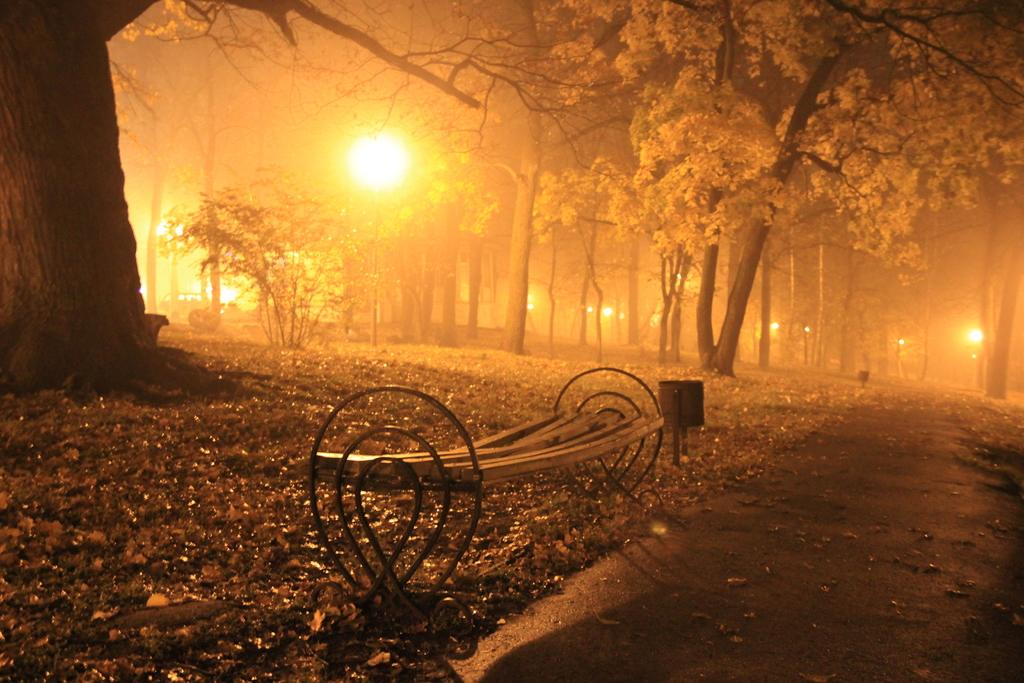What is located in the center of the image? There is a bench and a pole in the center of the image. What can be seen in the background of the image? There are trees and lights in the background of the image. What type of angle is the zipper on the bench in the image? There is no zipper present on the bench in the image. 